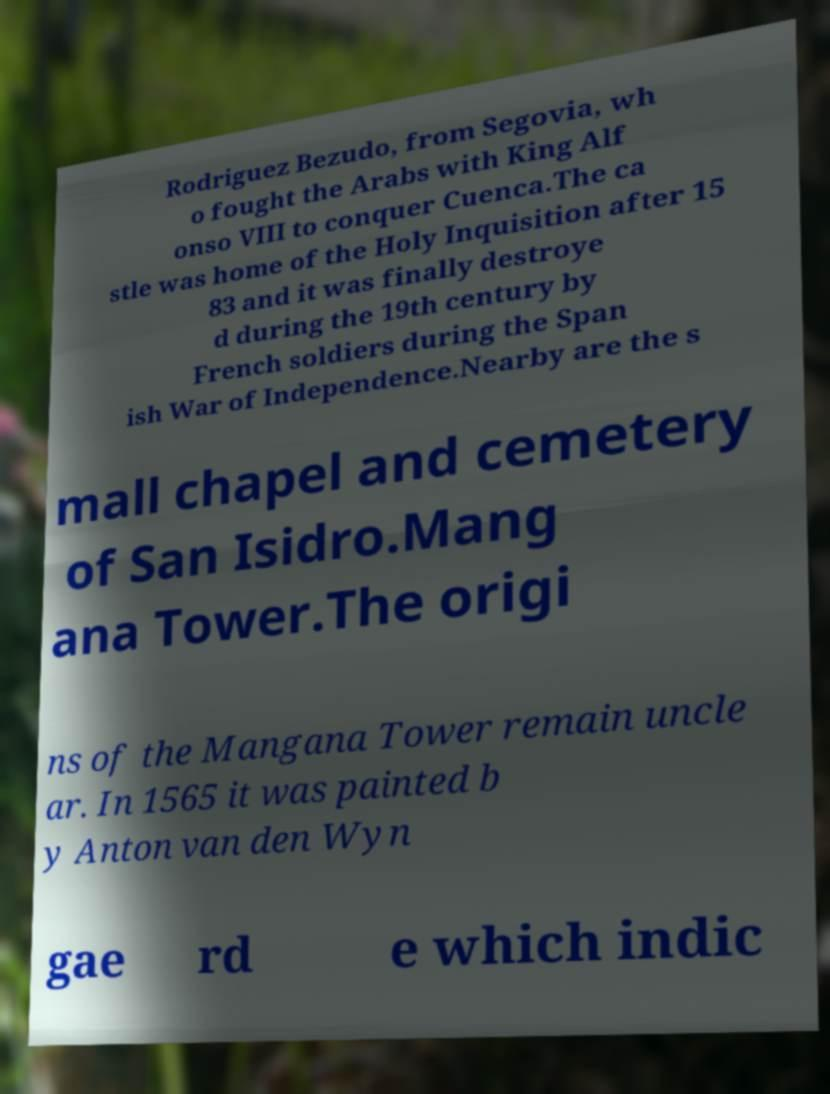Could you extract and type out the text from this image? Rodriguez Bezudo, from Segovia, wh o fought the Arabs with King Alf onso VIII to conquer Cuenca.The ca stle was home of the Holy Inquisition after 15 83 and it was finally destroye d during the 19th century by French soldiers during the Span ish War of Independence.Nearby are the s mall chapel and cemetery of San Isidro.Mang ana Tower.The origi ns of the Mangana Tower remain uncle ar. In 1565 it was painted b y Anton van den Wyn gae rd e which indic 